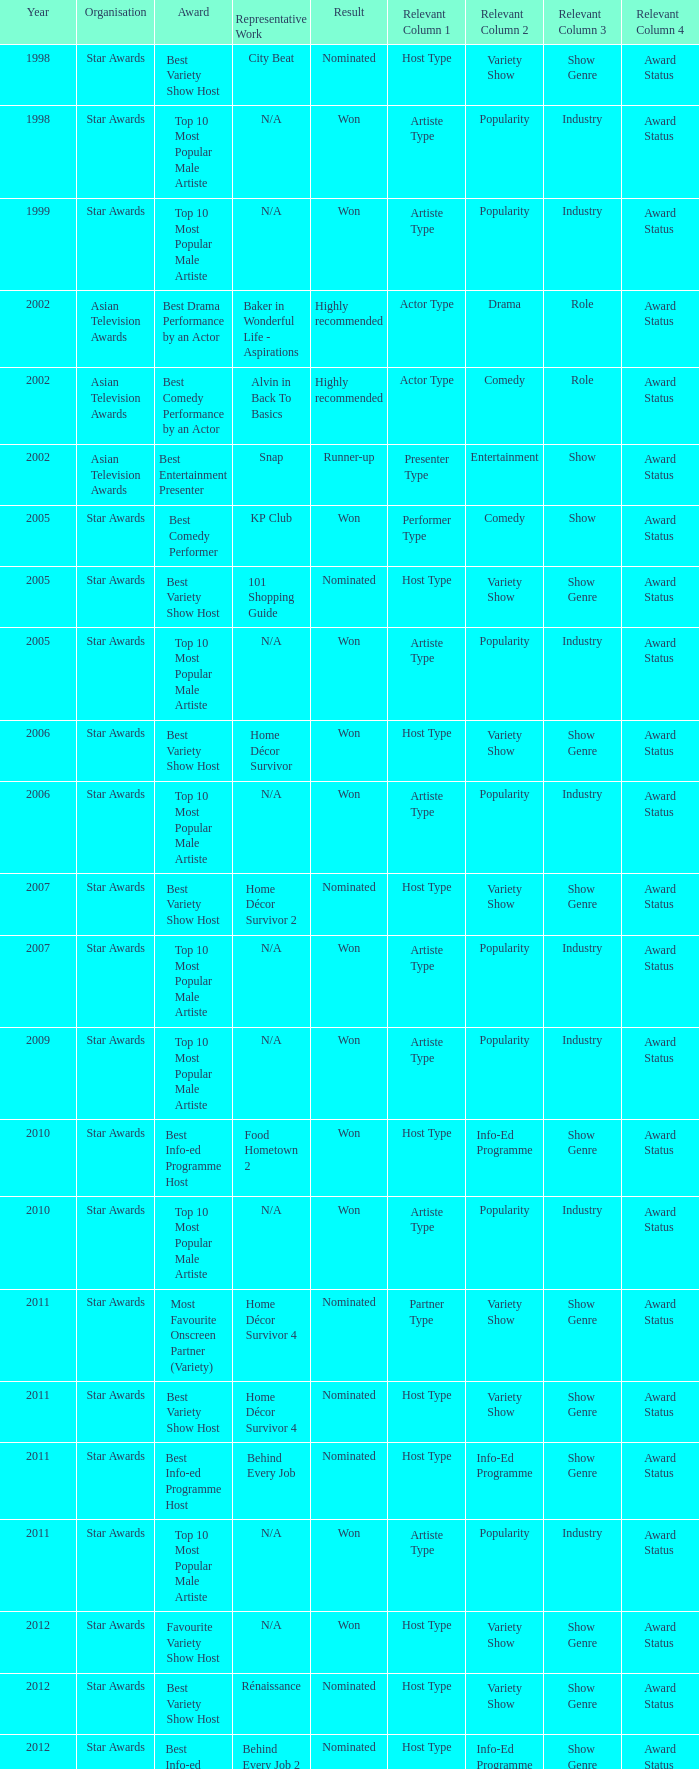What is the organisation in 2011 that was nominated and the award of best info-ed programme host? Star Awards. Give me the full table as a dictionary. {'header': ['Year', 'Organisation', 'Award', 'Representative Work', 'Result', 'Relevant Column 1', 'Relevant Column 2', 'Relevant Column 3', 'Relevant Column 4'], 'rows': [['1998', 'Star Awards', 'Best Variety Show Host', 'City Beat', 'Nominated', 'Host Type', 'Variety Show', 'Show Genre', 'Award Status'], ['1998', 'Star Awards', 'Top 10 Most Popular Male Artiste', 'N/A', 'Won', 'Artiste Type', 'Popularity', 'Industry', 'Award Status'], ['1999', 'Star Awards', 'Top 10 Most Popular Male Artiste', 'N/A', 'Won', 'Artiste Type', 'Popularity', 'Industry', 'Award Status'], ['2002', 'Asian Television Awards', 'Best Drama Performance by an Actor', 'Baker in Wonderful Life - Aspirations', 'Highly recommended', 'Actor Type', 'Drama', 'Role', 'Award Status'], ['2002', 'Asian Television Awards', 'Best Comedy Performance by an Actor', 'Alvin in Back To Basics', 'Highly recommended', 'Actor Type', 'Comedy', 'Role', 'Award Status'], ['2002', 'Asian Television Awards', 'Best Entertainment Presenter', 'Snap', 'Runner-up', 'Presenter Type', 'Entertainment', 'Show', 'Award Status'], ['2005', 'Star Awards', 'Best Comedy Performer', 'KP Club', 'Won', 'Performer Type', 'Comedy', 'Show', 'Award Status'], ['2005', 'Star Awards', 'Best Variety Show Host', '101 Shopping Guide', 'Nominated', 'Host Type', 'Variety Show', 'Show Genre', 'Award Status'], ['2005', 'Star Awards', 'Top 10 Most Popular Male Artiste', 'N/A', 'Won', 'Artiste Type', 'Popularity', 'Industry', 'Award Status'], ['2006', 'Star Awards', 'Best Variety Show Host', 'Home Décor Survivor', 'Won', 'Host Type', 'Variety Show', 'Show Genre', 'Award Status'], ['2006', 'Star Awards', 'Top 10 Most Popular Male Artiste', 'N/A', 'Won', 'Artiste Type', 'Popularity', 'Industry', 'Award Status'], ['2007', 'Star Awards', 'Best Variety Show Host', 'Home Décor Survivor 2', 'Nominated', 'Host Type', 'Variety Show', 'Show Genre', 'Award Status'], ['2007', 'Star Awards', 'Top 10 Most Popular Male Artiste', 'N/A', 'Won', 'Artiste Type', 'Popularity', 'Industry', 'Award Status'], ['2009', 'Star Awards', 'Top 10 Most Popular Male Artiste', 'N/A', 'Won', 'Artiste Type', 'Popularity', 'Industry', 'Award Status'], ['2010', 'Star Awards', 'Best Info-ed Programme Host', 'Food Hometown 2', 'Won', 'Host Type', 'Info-Ed Programme', 'Show Genre', 'Award Status'], ['2010', 'Star Awards', 'Top 10 Most Popular Male Artiste', 'N/A', 'Won', 'Artiste Type', 'Popularity', 'Industry', 'Award Status'], ['2011', 'Star Awards', 'Most Favourite Onscreen Partner (Variety)', 'Home Décor Survivor 4', 'Nominated', 'Partner Type', 'Variety Show', 'Show Genre', 'Award Status'], ['2011', 'Star Awards', 'Best Variety Show Host', 'Home Décor Survivor 4', 'Nominated', 'Host Type', 'Variety Show', 'Show Genre', 'Award Status'], ['2011', 'Star Awards', 'Best Info-ed Programme Host', 'Behind Every Job', 'Nominated', 'Host Type', 'Info-Ed Programme', 'Show Genre', 'Award Status'], ['2011', 'Star Awards', 'Top 10 Most Popular Male Artiste', 'N/A', 'Won', 'Artiste Type', 'Popularity', 'Industry', 'Award Status'], ['2012', 'Star Awards', 'Favourite Variety Show Host', 'N/A', 'Won', 'Host Type', 'Variety Show', 'Show Genre', 'Award Status'], ['2012', 'Star Awards', 'Best Variety Show Host', 'Rénaissance', 'Nominated', 'Host Type', 'Variety Show', 'Show Genre', 'Award Status'], ['2012', 'Star Awards', 'Best Info-ed Programme Host', 'Behind Every Job 2', 'Nominated', 'Host Type', 'Info-Ed Programme', 'Show Genre', 'Award Status'], ['2012', 'Star Awards', 'Top 10 Most Popular Male Artiste', 'N/A', 'Won', 'Artiste Type', 'Popularity', 'Industry', 'Award Status'], ['2013', 'Star Awards', 'Favourite Variety Show Host', 'S.N.A.P. 熠熠星光总动员', 'Won', 'Host Type', 'Variety Show', 'Show Genre', 'Award Status'], ['2013', 'Star Awards', 'Top 10 Most Popular Male Artiste', 'N/A', 'Won', 'Artiste Type', 'Popularity', 'Industry', 'Award Status'], ['2013', 'Star Awards', 'Best Info-Ed Programme Host', 'Makan Unlimited', 'Nominated', 'Host Type', 'Info-Ed Programme', 'Show Genre', 'Award Status'], ['2013', 'Star Awards', 'Best Variety Show Host', 'Jobs Around The World', 'Nominated', 'Host Type', 'Variety Show', 'Show Genre', 'Award Status']]} 